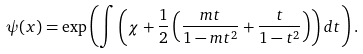<formula> <loc_0><loc_0><loc_500><loc_500>\psi ( x ) = \exp \left ( \int { \left ( \chi + \frac { 1 } { 2 } \left ( \frac { m t } { 1 - m t ^ { 2 } } + \frac { t } { 1 - t ^ { 2 } } \right ) \right ) d t } \right ) .</formula> 